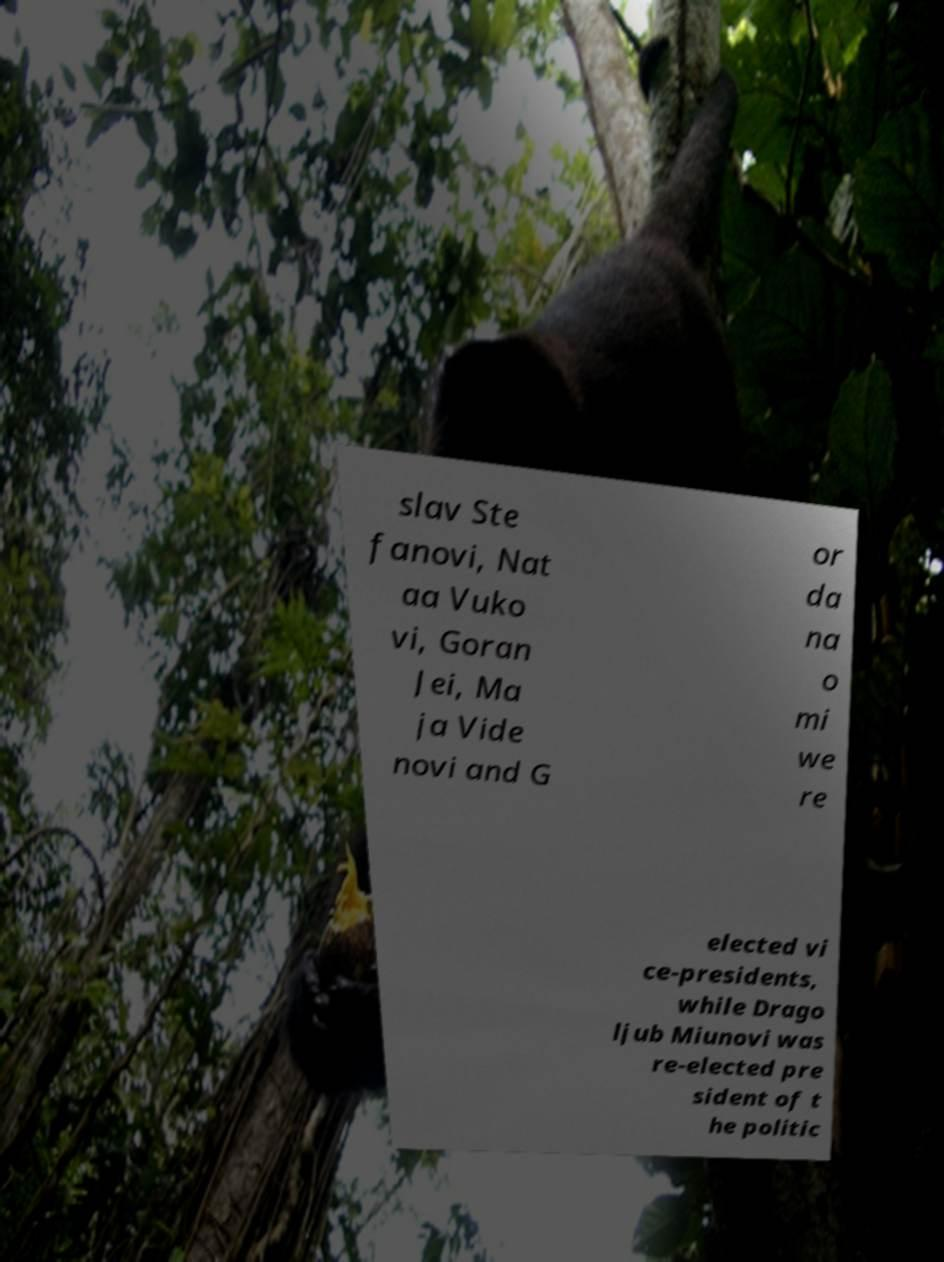Could you assist in decoding the text presented in this image and type it out clearly? slav Ste fanovi, Nat aa Vuko vi, Goran Jei, Ma ja Vide novi and G or da na o mi we re elected vi ce-presidents, while Drago ljub Miunovi was re-elected pre sident of t he politic 